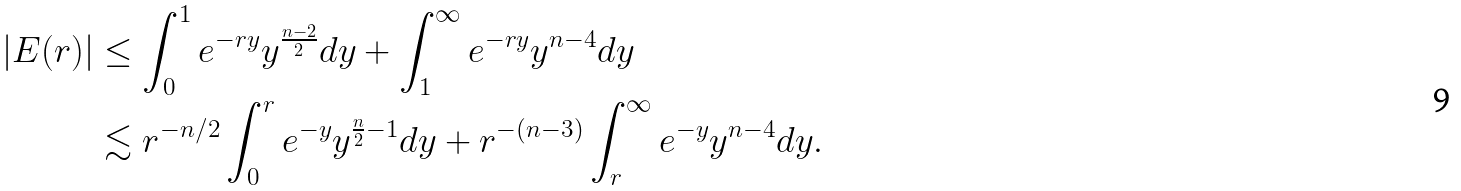Convert formula to latex. <formula><loc_0><loc_0><loc_500><loc_500>| E ( r ) | & \leq \int _ { 0 } ^ { 1 } e ^ { - r y } y ^ { \frac { n - 2 } { 2 } } d y + \int _ { 1 } ^ { \infty } e ^ { - r y } y ^ { n - 4 } d y \\ & \lesssim r ^ { - n / 2 } \int _ { 0 } ^ { r } e ^ { - y } y ^ { \frac { n } { 2 } - 1 } d y + r ^ { - ( n - 3 ) } \int _ { r } ^ { \infty } e ^ { - y } y ^ { n - 4 } d y .</formula> 